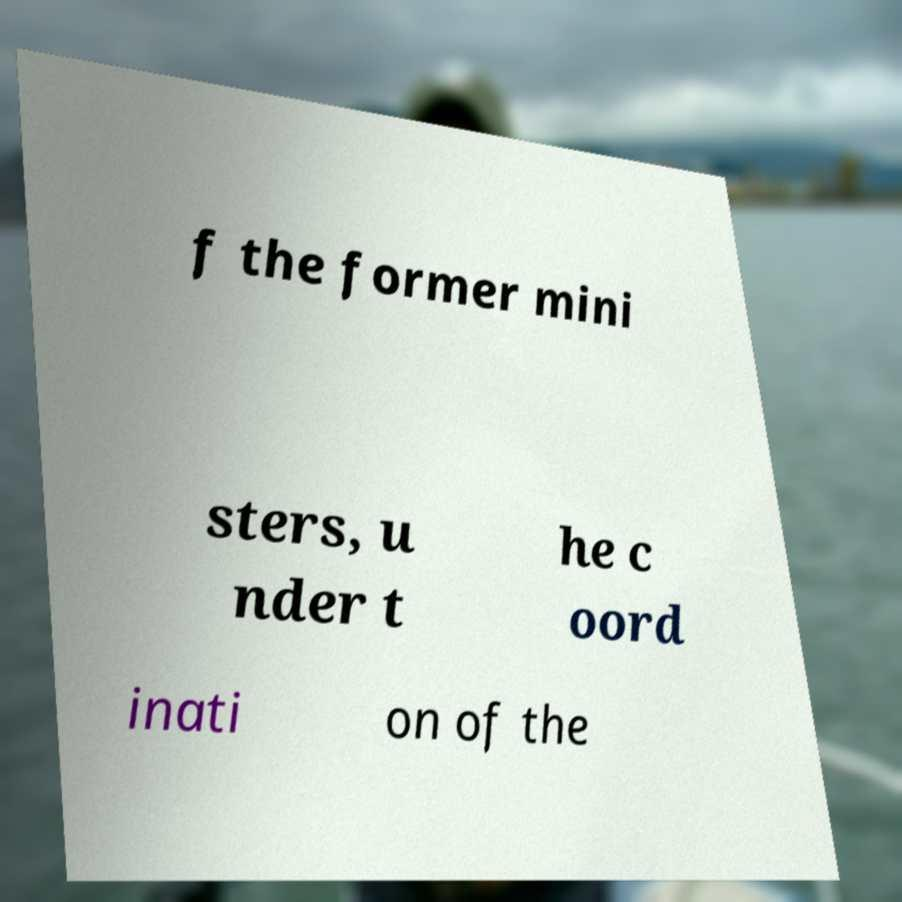Please read and relay the text visible in this image. What does it say? f the former mini sters, u nder t he c oord inati on of the 